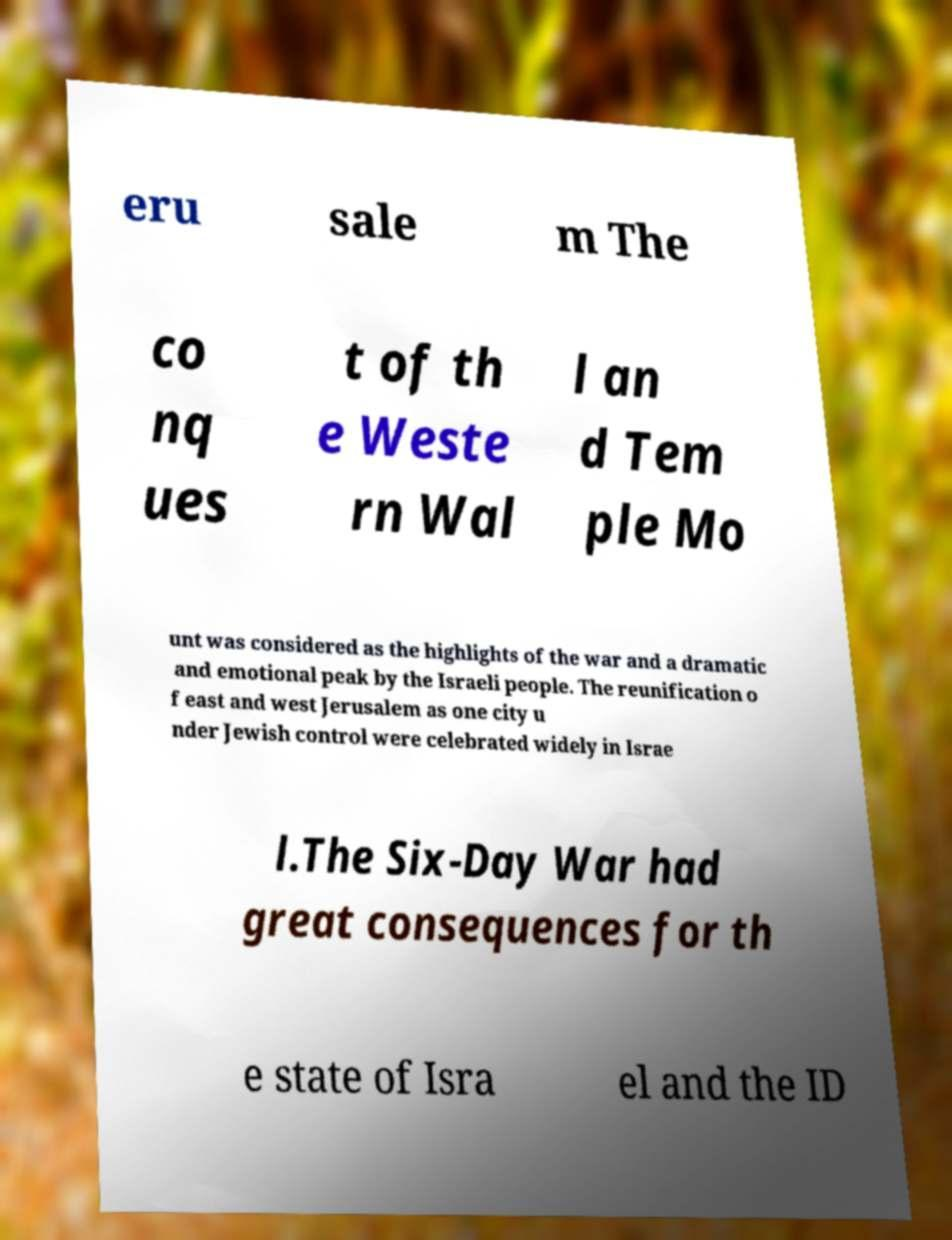There's text embedded in this image that I need extracted. Can you transcribe it verbatim? eru sale m The co nq ues t of th e Weste rn Wal l an d Tem ple Mo unt was considered as the highlights of the war and a dramatic and emotional peak by the Israeli people. The reunification o f east and west Jerusalem as one city u nder Jewish control were celebrated widely in Israe l.The Six-Day War had great consequences for th e state of Isra el and the ID 